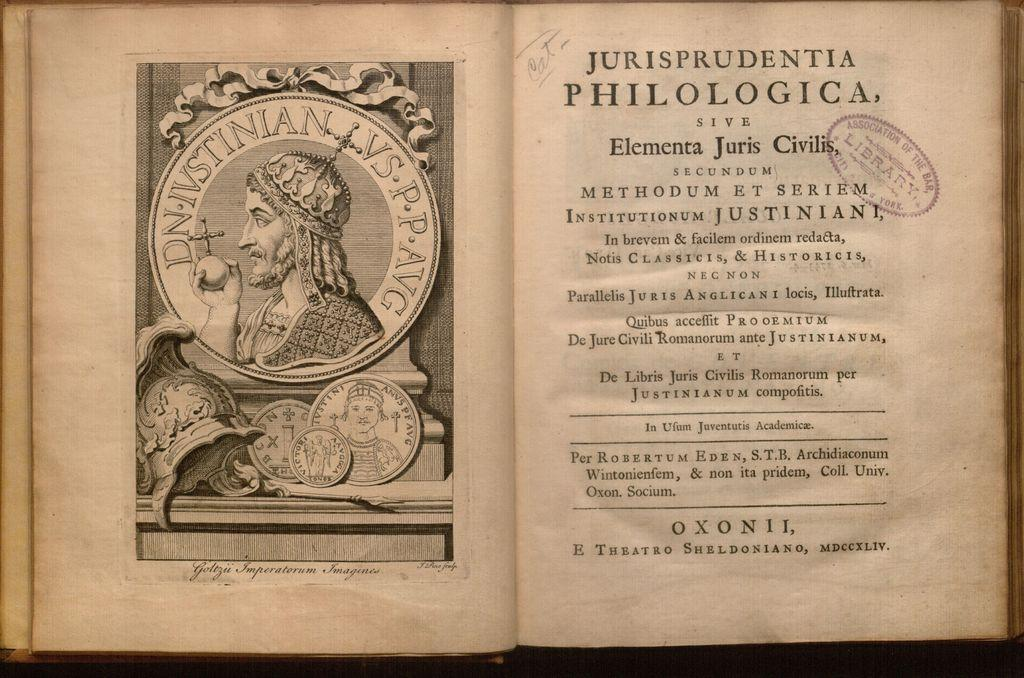<image>
Provide a brief description of the given image. Book open on a page that has the word "JURISPRUDENTIA PHILOLOGICA" on the top. 